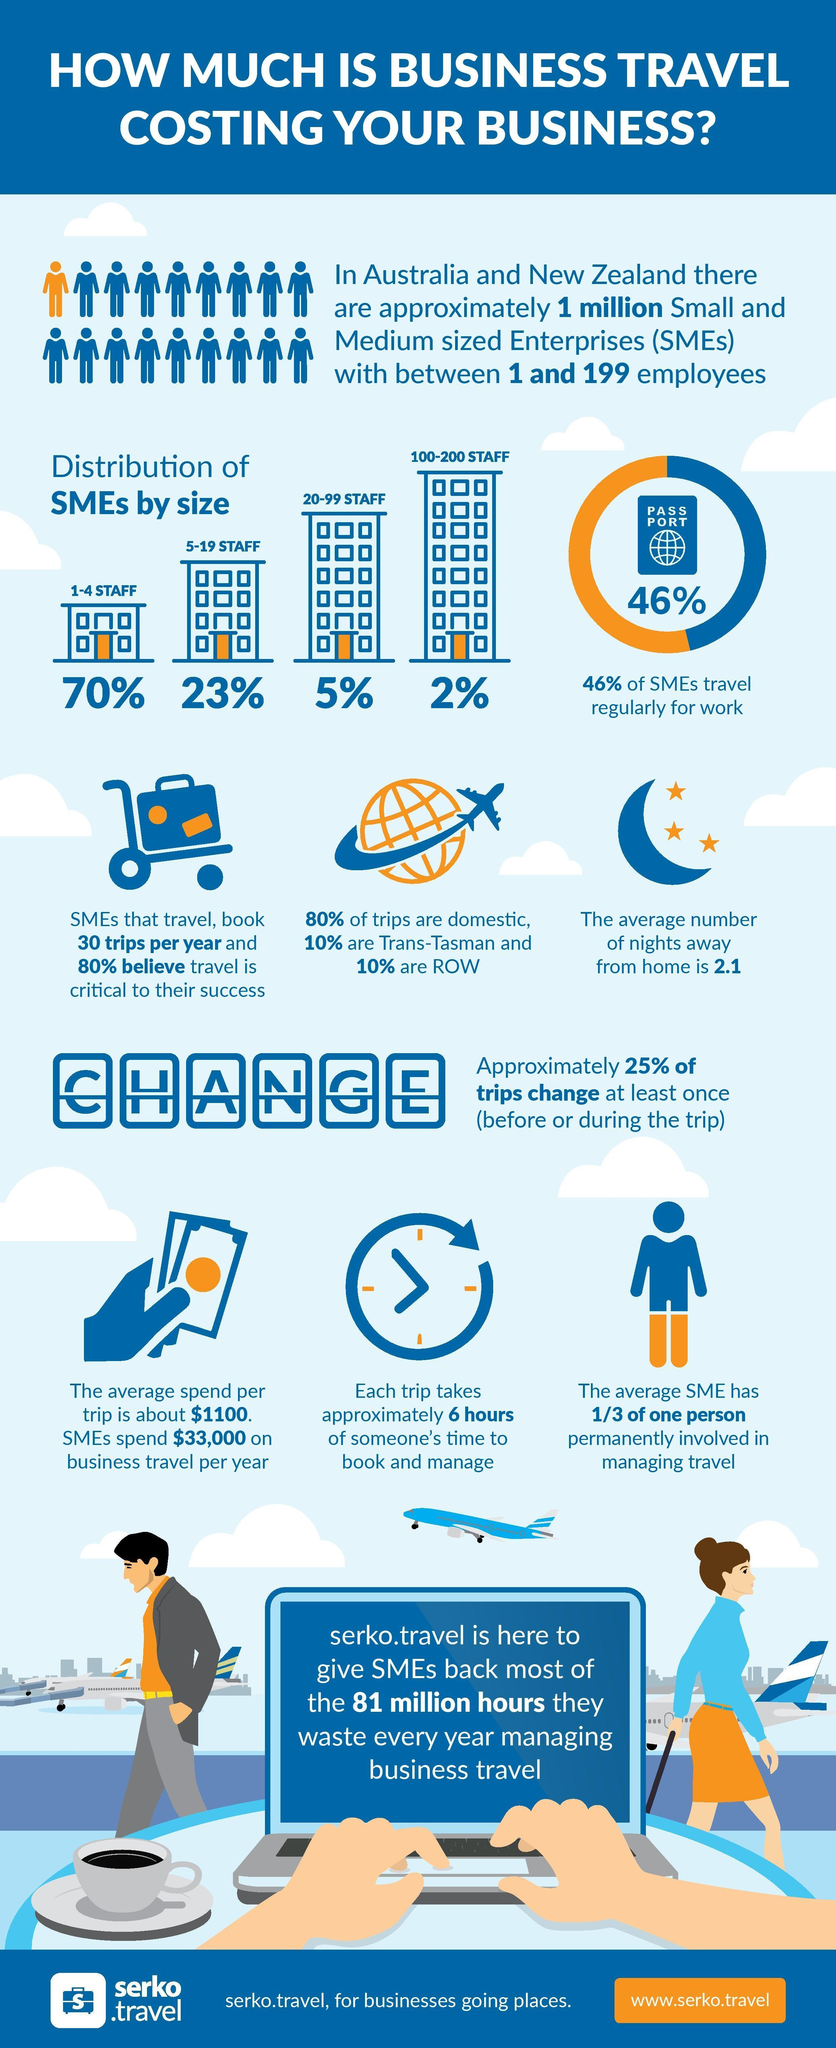How many women are shown in the infographic?
Answer the question with a short phrase. 1 What percent of SME s have 1-19 staff? 93% What percent of SMEs do not have to travel regularly? 54% What is the colour of shirt worn by the man -black, blue or orange? orange 